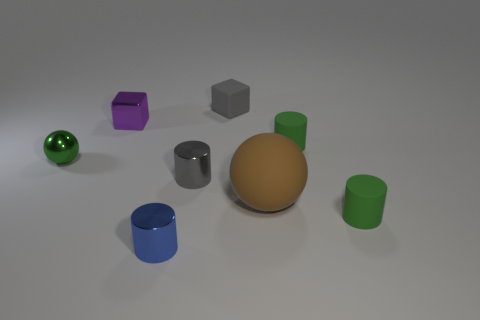How many other things are the same material as the brown sphere?
Ensure brevity in your answer.  3. Is the number of shiny blocks in front of the small purple metal thing greater than the number of tiny gray cylinders to the right of the tiny blue object?
Ensure brevity in your answer.  No. What number of tiny green rubber cylinders are on the left side of the purple thing?
Provide a short and direct response. 0. Does the tiny blue thing have the same material as the ball to the right of the small matte block?
Keep it short and to the point. No. Does the large brown sphere have the same material as the small gray cylinder?
Your answer should be very brief. No. There is a metal cylinder that is in front of the large matte object; are there any cylinders on the right side of it?
Your answer should be very brief. Yes. How many green objects are both to the left of the purple block and in front of the tiny ball?
Offer a terse response. 0. There is a small purple shiny object that is in front of the tiny gray matte thing; what shape is it?
Ensure brevity in your answer.  Cube. What number of rubber objects have the same size as the green metal thing?
Provide a succinct answer. 3. There is a matte cylinder in front of the gray metallic object; is its color the same as the tiny metallic sphere?
Keep it short and to the point. Yes. 